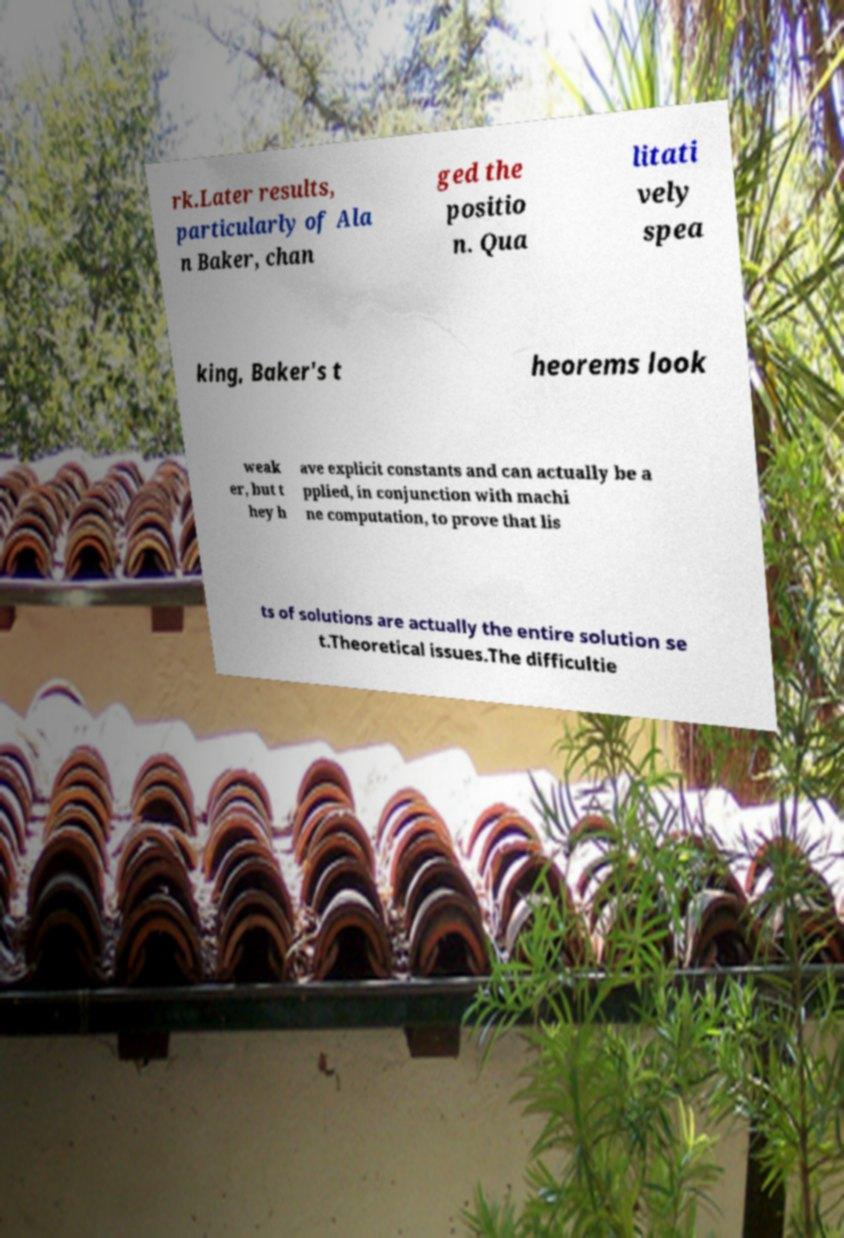Could you assist in decoding the text presented in this image and type it out clearly? rk.Later results, particularly of Ala n Baker, chan ged the positio n. Qua litati vely spea king, Baker's t heorems look weak er, but t hey h ave explicit constants and can actually be a pplied, in conjunction with machi ne computation, to prove that lis ts of solutions are actually the entire solution se t.Theoretical issues.The difficultie 